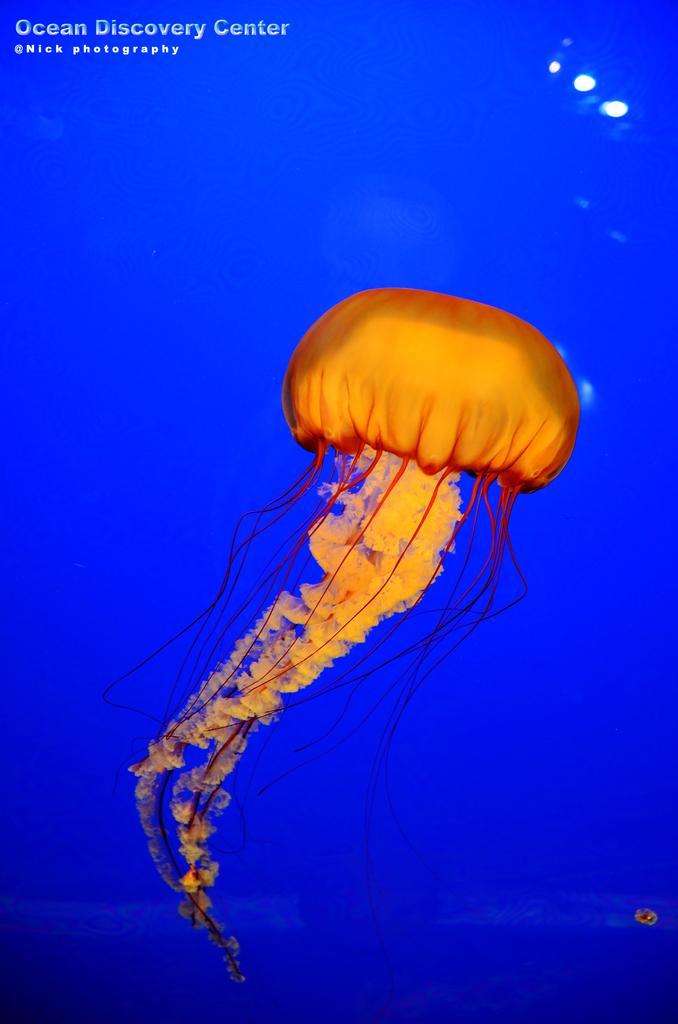Can you describe this image briefly? In this image I can see the jellyfish and the fish is in orange color and I can see the blue color background. 